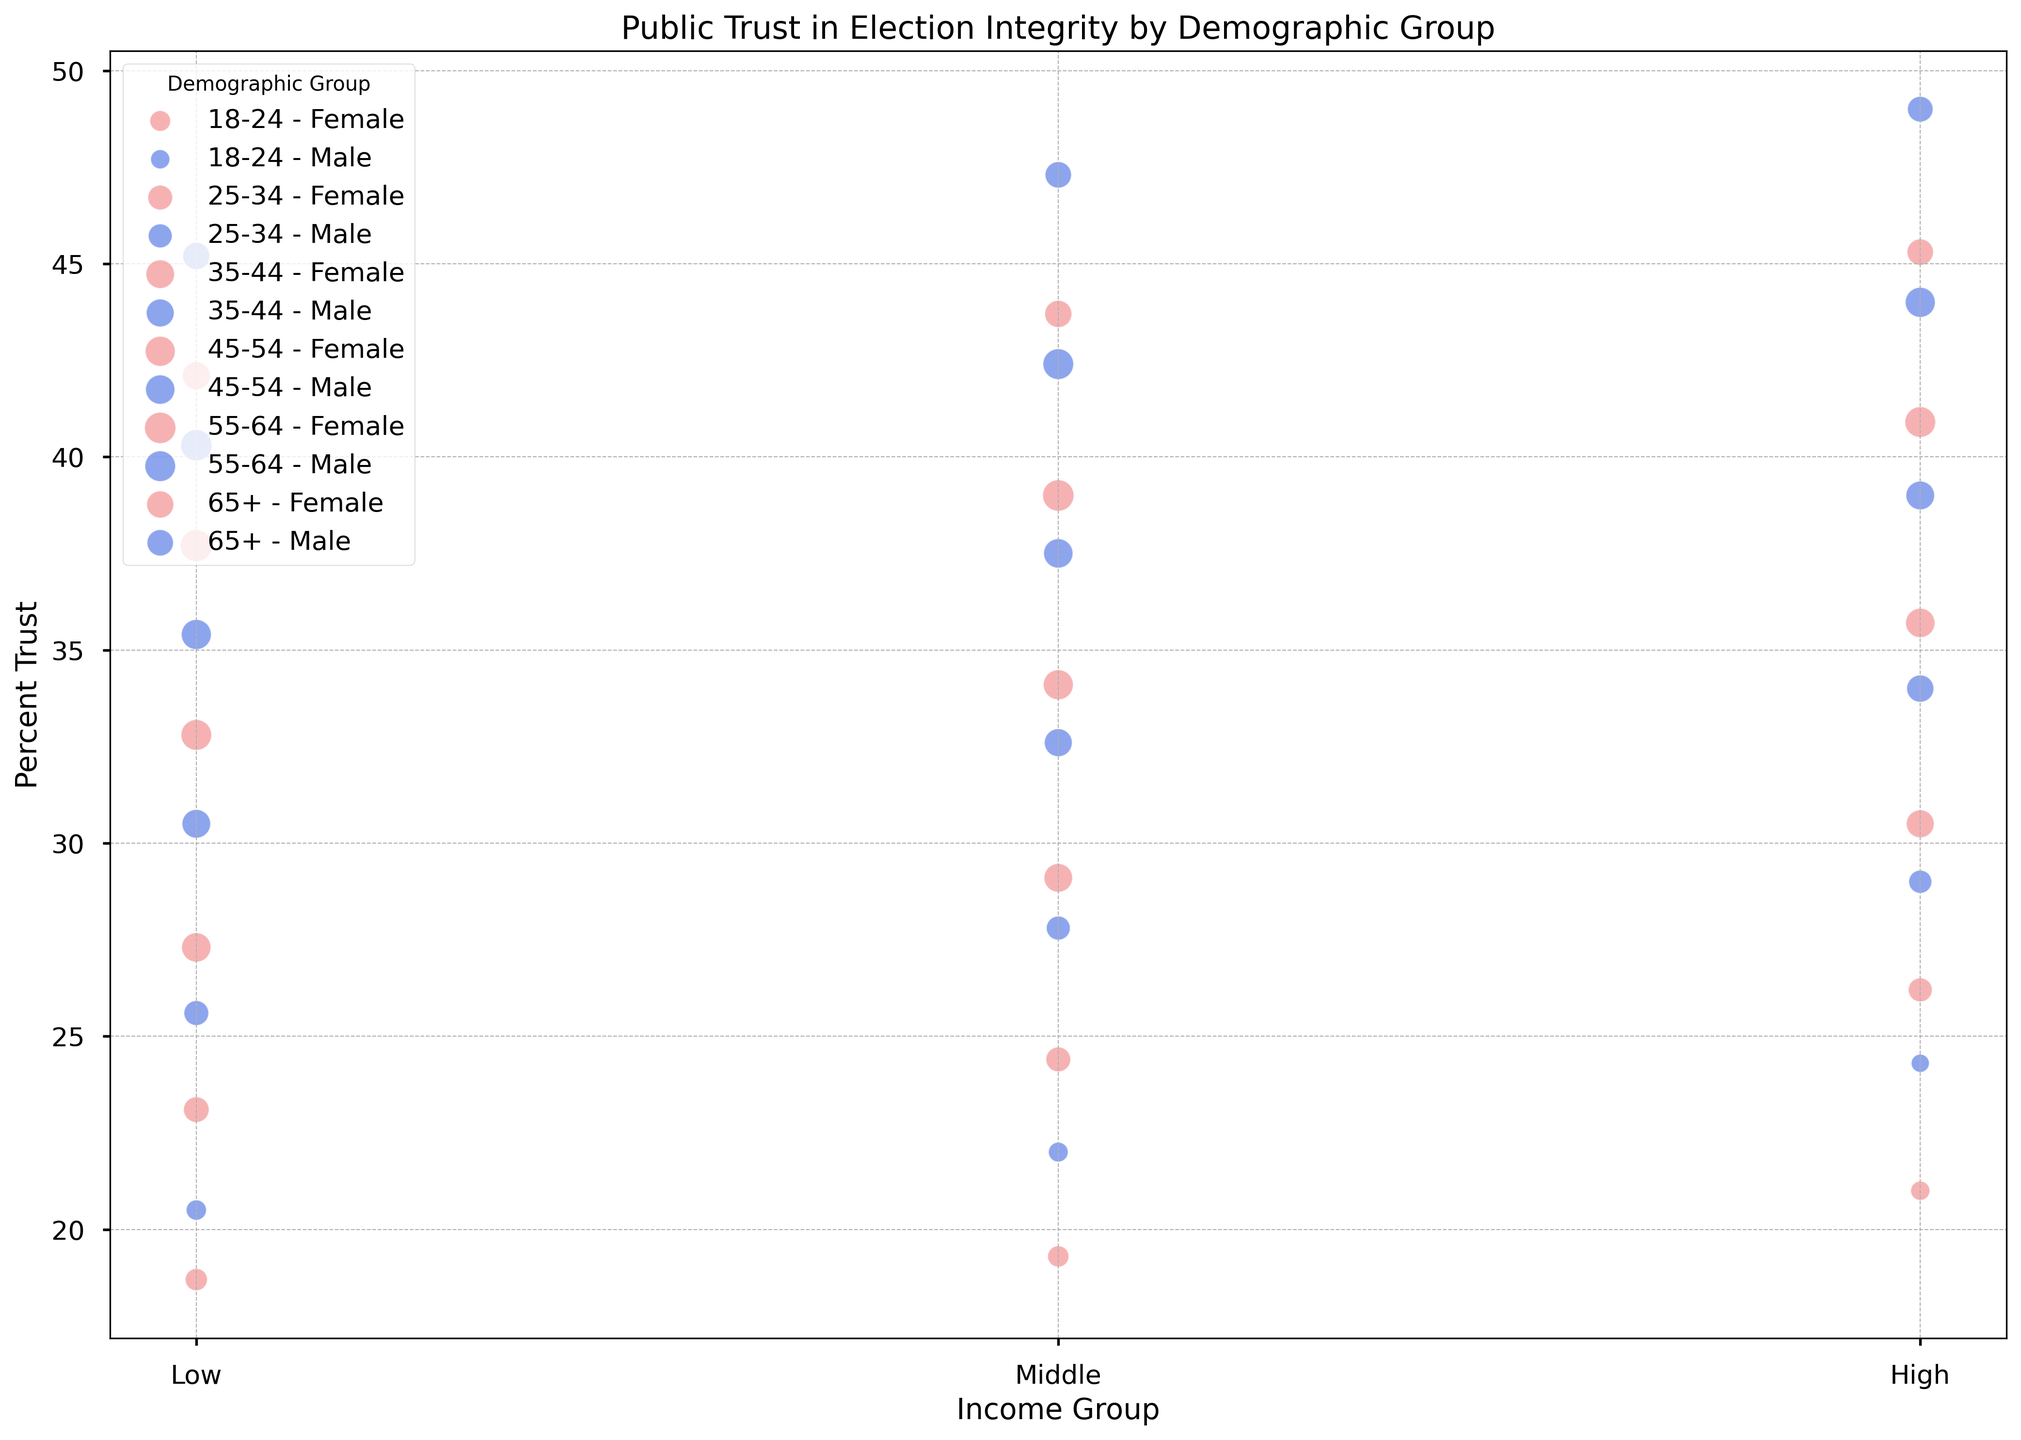What is the largest bubble size in the 45-54 age group? The largest bubble size in the 45-54 age group corresponds to the group with the highest number of people. From the data, the largest number of people in the 45-54 age group is 230 for females with low income.
Answer: 230 Which gender has higher trust in election integrity in the 18-24 age group? To determine this, compare the average percent trust for males and females in the 18-24 age group. For males: (20.5 + 22.0 + 24.3)/3 ≈ 22.27%. For females: (18.7 + 19.3 + 21.0)/3 ≈ 19.67%. Males have a higher trust.
Answer: Males How does trust in election integrity trend with age for males with middle income? To identify the trend, observe the percent trust values for males with middle income across different age groups: 18-24 (22.0), 25-34 (27.8), 35-44 (32.6), 45-54 (37.5), 55-64 (42.4), 65+ (47.3). The trend shows a consistent increase in trust with age.
Answer: Increases Compare the trust in election integrity between the 55-64 age group with low income and the 35-44 age group with high income for females. Retrieve the percent trust values: 55-64 low income females have 37.7% and 35-44 high income females have 30.5%. 55-64 low income females have higher trust.
Answer: 55-64 low income females What is the average percent trust for high income groups across all age groups? Average the percent trust values for high income groups: (24.3 + 21.0 + 29.0 + 26.2 + 34.0 + 30.5 + 39.0 + 35.7 + 44.0 + 40.9 + 49.0 + 45.3) / 12 ≈ 33.58%.
Answer: 33.58% Which income group and gender in the 65+ age group shows the lowest percent trust in election integrity? For the 65+ age group, compare percent trust values across different income groups and genders: Male Low (45.2), Female Low (42.1), Male Middle (47.3), Female Middle (43.7), Male High (49.0), Female High (45.3). The lowest value is for females with low income (42.1%).
Answer: Female Low Identify the demographic group with the highest percent trust in election integrity. Compare the highest percent trust values identified from the chart: The highest value overall is in the 65+ age group, high income males, which is 49.0%.
Answer: 65+ Male High Income What is the difference in percent trust between the highest income group and the lowest income group for the 25-34 age group? Calculate the percent trust difference for 25-34 age group: High income trust (Male: 29.0, Female: 26.2) and Low income trust (Male: 25.6, Female: 23.1). Average high income: (29.0 + 26.2)/2 = 27.6. Average low income: (25.6 + 23.1)/2 = 24.35. Difference is 27.6 - 24.35 = 3.25.
Answer: 3.25 For middle-income groups, what is the trend in percent trust as we move from younger to older age groups? Evaluate percent trust for middle income across age groups: 18-24 (20.7), 25-34 (26.1), 35-44 (30.85), 45-54 (35.8), 55-64 (40.7), 65+ (45.5). Trust generally increases from younger to older age groups.
Answer: Increases Are there any age groups where females have a higher trust in election integrity than males? By comparing each age group, identify: 
- 18-24: Males (22.0) vs. Females (19.67) – Males higher
- 25-34: Males (27.47) vs. Females (24.57) – Males higher
- 35-44: Males (32.37) vs. Females (28.97) – Males higher
- 45-54: Males (37.3) vs. Females (34.2) – Males higher
- 55-64: Males (42.23) vs. Females (39.2) – Males higher
- 65+: Males (47.2) vs. Females (43.7) – Males higher
There are no age groups where females have higher trust than males.
Answer: No 